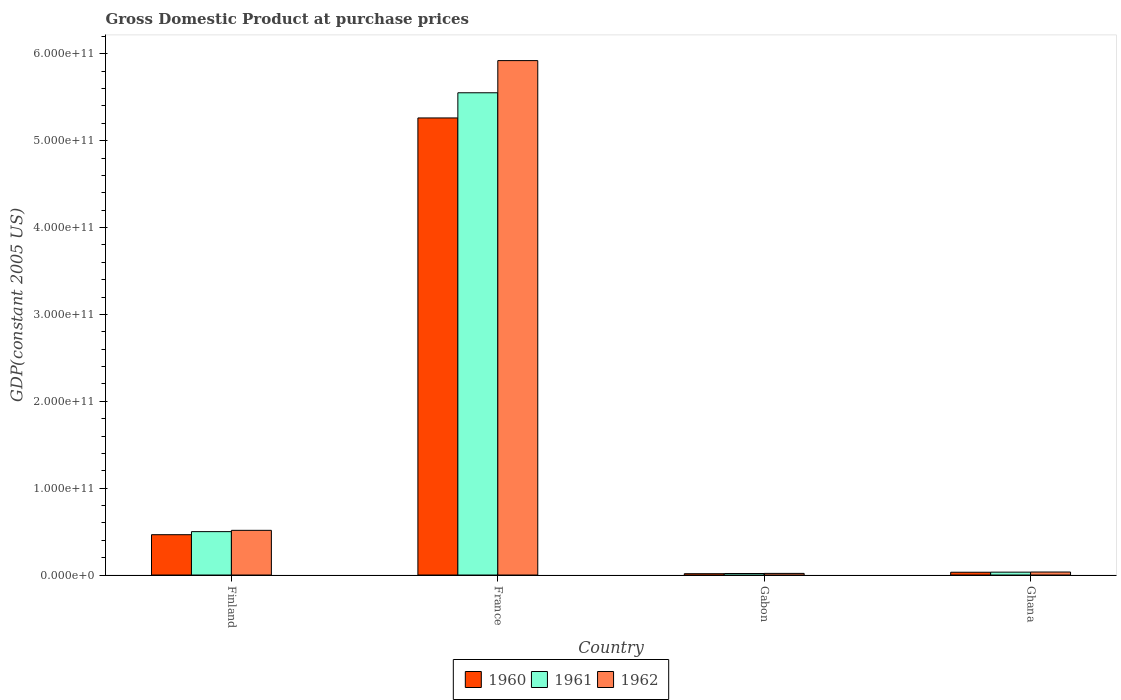Are the number of bars per tick equal to the number of legend labels?
Keep it short and to the point. Yes. Are the number of bars on each tick of the X-axis equal?
Your response must be concise. Yes. How many bars are there on the 2nd tick from the left?
Provide a succinct answer. 3. How many bars are there on the 1st tick from the right?
Your answer should be compact. 3. What is the label of the 2nd group of bars from the left?
Offer a terse response. France. What is the GDP at purchase prices in 1962 in Gabon?
Your answer should be very brief. 1.87e+09. Across all countries, what is the maximum GDP at purchase prices in 1961?
Provide a succinct answer. 5.55e+11. Across all countries, what is the minimum GDP at purchase prices in 1960?
Give a very brief answer. 1.52e+09. In which country was the GDP at purchase prices in 1961 maximum?
Offer a very short reply. France. In which country was the GDP at purchase prices in 1960 minimum?
Ensure brevity in your answer.  Gabon. What is the total GDP at purchase prices in 1960 in the graph?
Offer a very short reply. 5.77e+11. What is the difference between the GDP at purchase prices in 1960 in Finland and that in France?
Make the answer very short. -4.80e+11. What is the difference between the GDP at purchase prices in 1961 in Finland and the GDP at purchase prices in 1962 in Gabon?
Provide a succinct answer. 4.81e+1. What is the average GDP at purchase prices in 1961 per country?
Ensure brevity in your answer.  1.53e+11. What is the difference between the GDP at purchase prices of/in 1961 and GDP at purchase prices of/in 1962 in Ghana?
Your response must be concise. -1.36e+08. In how many countries, is the GDP at purchase prices in 1962 greater than 340000000000 US$?
Provide a succinct answer. 1. What is the ratio of the GDP at purchase prices in 1961 in Gabon to that in Ghana?
Offer a very short reply. 0.53. Is the GDP at purchase prices in 1962 in Gabon less than that in Ghana?
Your answer should be very brief. Yes. What is the difference between the highest and the second highest GDP at purchase prices in 1962?
Provide a short and direct response. 5.89e+11. What is the difference between the highest and the lowest GDP at purchase prices in 1960?
Ensure brevity in your answer.  5.25e+11. Is it the case that in every country, the sum of the GDP at purchase prices in 1962 and GDP at purchase prices in 1961 is greater than the GDP at purchase prices in 1960?
Your response must be concise. Yes. Are all the bars in the graph horizontal?
Provide a short and direct response. No. What is the difference between two consecutive major ticks on the Y-axis?
Make the answer very short. 1.00e+11. Where does the legend appear in the graph?
Your answer should be very brief. Bottom center. How many legend labels are there?
Your answer should be compact. 3. How are the legend labels stacked?
Offer a terse response. Horizontal. What is the title of the graph?
Offer a very short reply. Gross Domestic Product at purchase prices. Does "1970" appear as one of the legend labels in the graph?
Make the answer very short. No. What is the label or title of the X-axis?
Give a very brief answer. Country. What is the label or title of the Y-axis?
Provide a short and direct response. GDP(constant 2005 US). What is the GDP(constant 2005 US) in 1960 in Finland?
Offer a very short reply. 4.64e+1. What is the GDP(constant 2005 US) of 1961 in Finland?
Provide a short and direct response. 4.99e+1. What is the GDP(constant 2005 US) of 1962 in Finland?
Provide a short and direct response. 5.14e+1. What is the GDP(constant 2005 US) of 1960 in France?
Provide a short and direct response. 5.26e+11. What is the GDP(constant 2005 US) of 1961 in France?
Provide a succinct answer. 5.55e+11. What is the GDP(constant 2005 US) in 1962 in France?
Provide a short and direct response. 5.92e+11. What is the GDP(constant 2005 US) of 1960 in Gabon?
Give a very brief answer. 1.52e+09. What is the GDP(constant 2005 US) in 1961 in Gabon?
Offer a very short reply. 1.74e+09. What is the GDP(constant 2005 US) of 1962 in Gabon?
Your answer should be compact. 1.87e+09. What is the GDP(constant 2005 US) in 1960 in Ghana?
Your response must be concise. 3.20e+09. What is the GDP(constant 2005 US) of 1961 in Ghana?
Provide a short and direct response. 3.31e+09. What is the GDP(constant 2005 US) of 1962 in Ghana?
Your answer should be compact. 3.45e+09. Across all countries, what is the maximum GDP(constant 2005 US) in 1960?
Give a very brief answer. 5.26e+11. Across all countries, what is the maximum GDP(constant 2005 US) of 1961?
Your response must be concise. 5.55e+11. Across all countries, what is the maximum GDP(constant 2005 US) in 1962?
Your answer should be compact. 5.92e+11. Across all countries, what is the minimum GDP(constant 2005 US) in 1960?
Ensure brevity in your answer.  1.52e+09. Across all countries, what is the minimum GDP(constant 2005 US) in 1961?
Make the answer very short. 1.74e+09. Across all countries, what is the minimum GDP(constant 2005 US) in 1962?
Make the answer very short. 1.87e+09. What is the total GDP(constant 2005 US) of 1960 in the graph?
Your answer should be compact. 5.77e+11. What is the total GDP(constant 2005 US) of 1961 in the graph?
Your answer should be very brief. 6.10e+11. What is the total GDP(constant 2005 US) of 1962 in the graph?
Ensure brevity in your answer.  6.49e+11. What is the difference between the GDP(constant 2005 US) in 1960 in Finland and that in France?
Provide a short and direct response. -4.80e+11. What is the difference between the GDP(constant 2005 US) of 1961 in Finland and that in France?
Make the answer very short. -5.05e+11. What is the difference between the GDP(constant 2005 US) in 1962 in Finland and that in France?
Make the answer very short. -5.41e+11. What is the difference between the GDP(constant 2005 US) of 1960 in Finland and that in Gabon?
Provide a succinct answer. 4.49e+1. What is the difference between the GDP(constant 2005 US) of 1961 in Finland and that in Gabon?
Provide a short and direct response. 4.82e+1. What is the difference between the GDP(constant 2005 US) in 1962 in Finland and that in Gabon?
Make the answer very short. 4.96e+1. What is the difference between the GDP(constant 2005 US) in 1960 in Finland and that in Ghana?
Offer a terse response. 4.32e+1. What is the difference between the GDP(constant 2005 US) in 1961 in Finland and that in Ghana?
Your answer should be compact. 4.66e+1. What is the difference between the GDP(constant 2005 US) in 1962 in Finland and that in Ghana?
Provide a succinct answer. 4.80e+1. What is the difference between the GDP(constant 2005 US) of 1960 in France and that in Gabon?
Your response must be concise. 5.25e+11. What is the difference between the GDP(constant 2005 US) of 1961 in France and that in Gabon?
Provide a short and direct response. 5.53e+11. What is the difference between the GDP(constant 2005 US) of 1962 in France and that in Gabon?
Provide a succinct answer. 5.90e+11. What is the difference between the GDP(constant 2005 US) of 1960 in France and that in Ghana?
Offer a very short reply. 5.23e+11. What is the difference between the GDP(constant 2005 US) of 1961 in France and that in Ghana?
Ensure brevity in your answer.  5.52e+11. What is the difference between the GDP(constant 2005 US) of 1962 in France and that in Ghana?
Your answer should be compact. 5.89e+11. What is the difference between the GDP(constant 2005 US) in 1960 in Gabon and that in Ghana?
Provide a succinct answer. -1.68e+09. What is the difference between the GDP(constant 2005 US) of 1961 in Gabon and that in Ghana?
Make the answer very short. -1.57e+09. What is the difference between the GDP(constant 2005 US) in 1962 in Gabon and that in Ghana?
Ensure brevity in your answer.  -1.58e+09. What is the difference between the GDP(constant 2005 US) of 1960 in Finland and the GDP(constant 2005 US) of 1961 in France?
Provide a short and direct response. -5.09e+11. What is the difference between the GDP(constant 2005 US) in 1960 in Finland and the GDP(constant 2005 US) in 1962 in France?
Your answer should be very brief. -5.46e+11. What is the difference between the GDP(constant 2005 US) of 1961 in Finland and the GDP(constant 2005 US) of 1962 in France?
Keep it short and to the point. -5.42e+11. What is the difference between the GDP(constant 2005 US) in 1960 in Finland and the GDP(constant 2005 US) in 1961 in Gabon?
Your answer should be very brief. 4.47e+1. What is the difference between the GDP(constant 2005 US) of 1960 in Finland and the GDP(constant 2005 US) of 1962 in Gabon?
Provide a succinct answer. 4.45e+1. What is the difference between the GDP(constant 2005 US) in 1961 in Finland and the GDP(constant 2005 US) in 1962 in Gabon?
Make the answer very short. 4.81e+1. What is the difference between the GDP(constant 2005 US) in 1960 in Finland and the GDP(constant 2005 US) in 1961 in Ghana?
Provide a succinct answer. 4.31e+1. What is the difference between the GDP(constant 2005 US) in 1960 in Finland and the GDP(constant 2005 US) in 1962 in Ghana?
Offer a very short reply. 4.30e+1. What is the difference between the GDP(constant 2005 US) of 1961 in Finland and the GDP(constant 2005 US) of 1962 in Ghana?
Make the answer very short. 4.65e+1. What is the difference between the GDP(constant 2005 US) of 1960 in France and the GDP(constant 2005 US) of 1961 in Gabon?
Your answer should be compact. 5.24e+11. What is the difference between the GDP(constant 2005 US) in 1960 in France and the GDP(constant 2005 US) in 1962 in Gabon?
Provide a short and direct response. 5.24e+11. What is the difference between the GDP(constant 2005 US) of 1961 in France and the GDP(constant 2005 US) of 1962 in Gabon?
Your response must be concise. 5.53e+11. What is the difference between the GDP(constant 2005 US) of 1960 in France and the GDP(constant 2005 US) of 1961 in Ghana?
Give a very brief answer. 5.23e+11. What is the difference between the GDP(constant 2005 US) in 1960 in France and the GDP(constant 2005 US) in 1962 in Ghana?
Your answer should be very brief. 5.23e+11. What is the difference between the GDP(constant 2005 US) in 1961 in France and the GDP(constant 2005 US) in 1962 in Ghana?
Your response must be concise. 5.52e+11. What is the difference between the GDP(constant 2005 US) in 1960 in Gabon and the GDP(constant 2005 US) in 1961 in Ghana?
Ensure brevity in your answer.  -1.79e+09. What is the difference between the GDP(constant 2005 US) in 1960 in Gabon and the GDP(constant 2005 US) in 1962 in Ghana?
Provide a succinct answer. -1.93e+09. What is the difference between the GDP(constant 2005 US) of 1961 in Gabon and the GDP(constant 2005 US) of 1962 in Ghana?
Give a very brief answer. -1.71e+09. What is the average GDP(constant 2005 US) of 1960 per country?
Your answer should be very brief. 1.44e+11. What is the average GDP(constant 2005 US) in 1961 per country?
Provide a succinct answer. 1.53e+11. What is the average GDP(constant 2005 US) in 1962 per country?
Offer a terse response. 1.62e+11. What is the difference between the GDP(constant 2005 US) of 1960 and GDP(constant 2005 US) of 1961 in Finland?
Offer a terse response. -3.53e+09. What is the difference between the GDP(constant 2005 US) in 1960 and GDP(constant 2005 US) in 1962 in Finland?
Ensure brevity in your answer.  -5.02e+09. What is the difference between the GDP(constant 2005 US) of 1961 and GDP(constant 2005 US) of 1962 in Finland?
Ensure brevity in your answer.  -1.49e+09. What is the difference between the GDP(constant 2005 US) in 1960 and GDP(constant 2005 US) in 1961 in France?
Give a very brief answer. -2.90e+1. What is the difference between the GDP(constant 2005 US) of 1960 and GDP(constant 2005 US) of 1962 in France?
Provide a succinct answer. -6.60e+1. What is the difference between the GDP(constant 2005 US) in 1961 and GDP(constant 2005 US) in 1962 in France?
Ensure brevity in your answer.  -3.70e+1. What is the difference between the GDP(constant 2005 US) in 1960 and GDP(constant 2005 US) in 1961 in Gabon?
Your answer should be compact. -2.24e+08. What is the difference between the GDP(constant 2005 US) in 1960 and GDP(constant 2005 US) in 1962 in Gabon?
Give a very brief answer. -3.54e+08. What is the difference between the GDP(constant 2005 US) of 1961 and GDP(constant 2005 US) of 1962 in Gabon?
Your answer should be compact. -1.30e+08. What is the difference between the GDP(constant 2005 US) of 1960 and GDP(constant 2005 US) of 1961 in Ghana?
Ensure brevity in your answer.  -1.10e+08. What is the difference between the GDP(constant 2005 US) in 1960 and GDP(constant 2005 US) in 1962 in Ghana?
Your response must be concise. -2.46e+08. What is the difference between the GDP(constant 2005 US) of 1961 and GDP(constant 2005 US) of 1962 in Ghana?
Provide a short and direct response. -1.36e+08. What is the ratio of the GDP(constant 2005 US) in 1960 in Finland to that in France?
Provide a short and direct response. 0.09. What is the ratio of the GDP(constant 2005 US) of 1961 in Finland to that in France?
Keep it short and to the point. 0.09. What is the ratio of the GDP(constant 2005 US) in 1962 in Finland to that in France?
Make the answer very short. 0.09. What is the ratio of the GDP(constant 2005 US) of 1960 in Finland to that in Gabon?
Offer a very short reply. 30.55. What is the ratio of the GDP(constant 2005 US) of 1961 in Finland to that in Gabon?
Make the answer very short. 28.64. What is the ratio of the GDP(constant 2005 US) in 1962 in Finland to that in Gabon?
Your answer should be very brief. 27.45. What is the ratio of the GDP(constant 2005 US) in 1960 in Finland to that in Ghana?
Offer a very short reply. 14.49. What is the ratio of the GDP(constant 2005 US) in 1961 in Finland to that in Ghana?
Provide a succinct answer. 15.07. What is the ratio of the GDP(constant 2005 US) of 1962 in Finland to that in Ghana?
Your response must be concise. 14.91. What is the ratio of the GDP(constant 2005 US) in 1960 in France to that in Gabon?
Give a very brief answer. 346.25. What is the ratio of the GDP(constant 2005 US) in 1961 in France to that in Gabon?
Provide a succinct answer. 318.31. What is the ratio of the GDP(constant 2005 US) of 1962 in France to that in Gabon?
Ensure brevity in your answer.  316. What is the ratio of the GDP(constant 2005 US) in 1960 in France to that in Ghana?
Provide a short and direct response. 164.23. What is the ratio of the GDP(constant 2005 US) of 1961 in France to that in Ghana?
Give a very brief answer. 167.52. What is the ratio of the GDP(constant 2005 US) of 1962 in France to that in Ghana?
Your response must be concise. 171.65. What is the ratio of the GDP(constant 2005 US) in 1960 in Gabon to that in Ghana?
Provide a succinct answer. 0.47. What is the ratio of the GDP(constant 2005 US) in 1961 in Gabon to that in Ghana?
Make the answer very short. 0.53. What is the ratio of the GDP(constant 2005 US) in 1962 in Gabon to that in Ghana?
Your response must be concise. 0.54. What is the difference between the highest and the second highest GDP(constant 2005 US) in 1960?
Offer a terse response. 4.80e+11. What is the difference between the highest and the second highest GDP(constant 2005 US) in 1961?
Your answer should be compact. 5.05e+11. What is the difference between the highest and the second highest GDP(constant 2005 US) in 1962?
Keep it short and to the point. 5.41e+11. What is the difference between the highest and the lowest GDP(constant 2005 US) in 1960?
Offer a very short reply. 5.25e+11. What is the difference between the highest and the lowest GDP(constant 2005 US) of 1961?
Your answer should be very brief. 5.53e+11. What is the difference between the highest and the lowest GDP(constant 2005 US) in 1962?
Ensure brevity in your answer.  5.90e+11. 